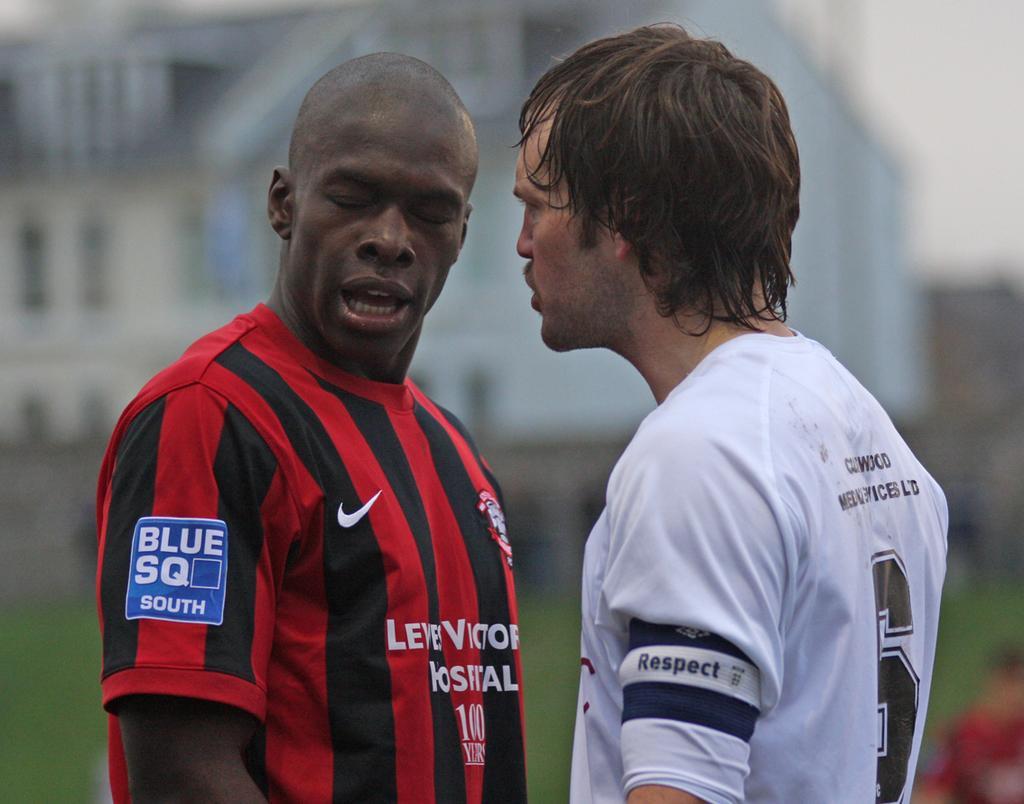Can you describe this image briefly? As we can see in the image in the front there are two people standing. The man on the right side is wearing white color t shirt. The man on the left side is wearing black and red color t shirt. In the background there is a building and the background is blurred. 